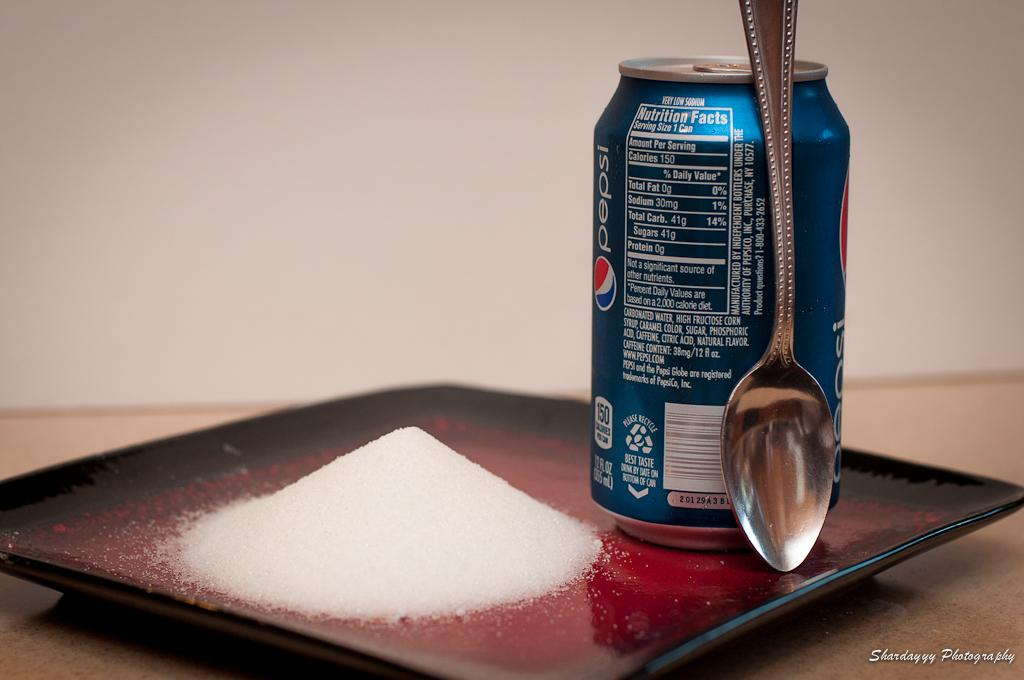<image>
Offer a succinct explanation of the picture presented. A can of pepsi sits on a plate with a spoon and a pile of sugar to show what the sugar content looks like in Pepsi 